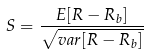<formula> <loc_0><loc_0><loc_500><loc_500>S = \frac { E [ R - R _ { b } ] } { \sqrt { v a r [ R - R _ { b } ] } }</formula> 